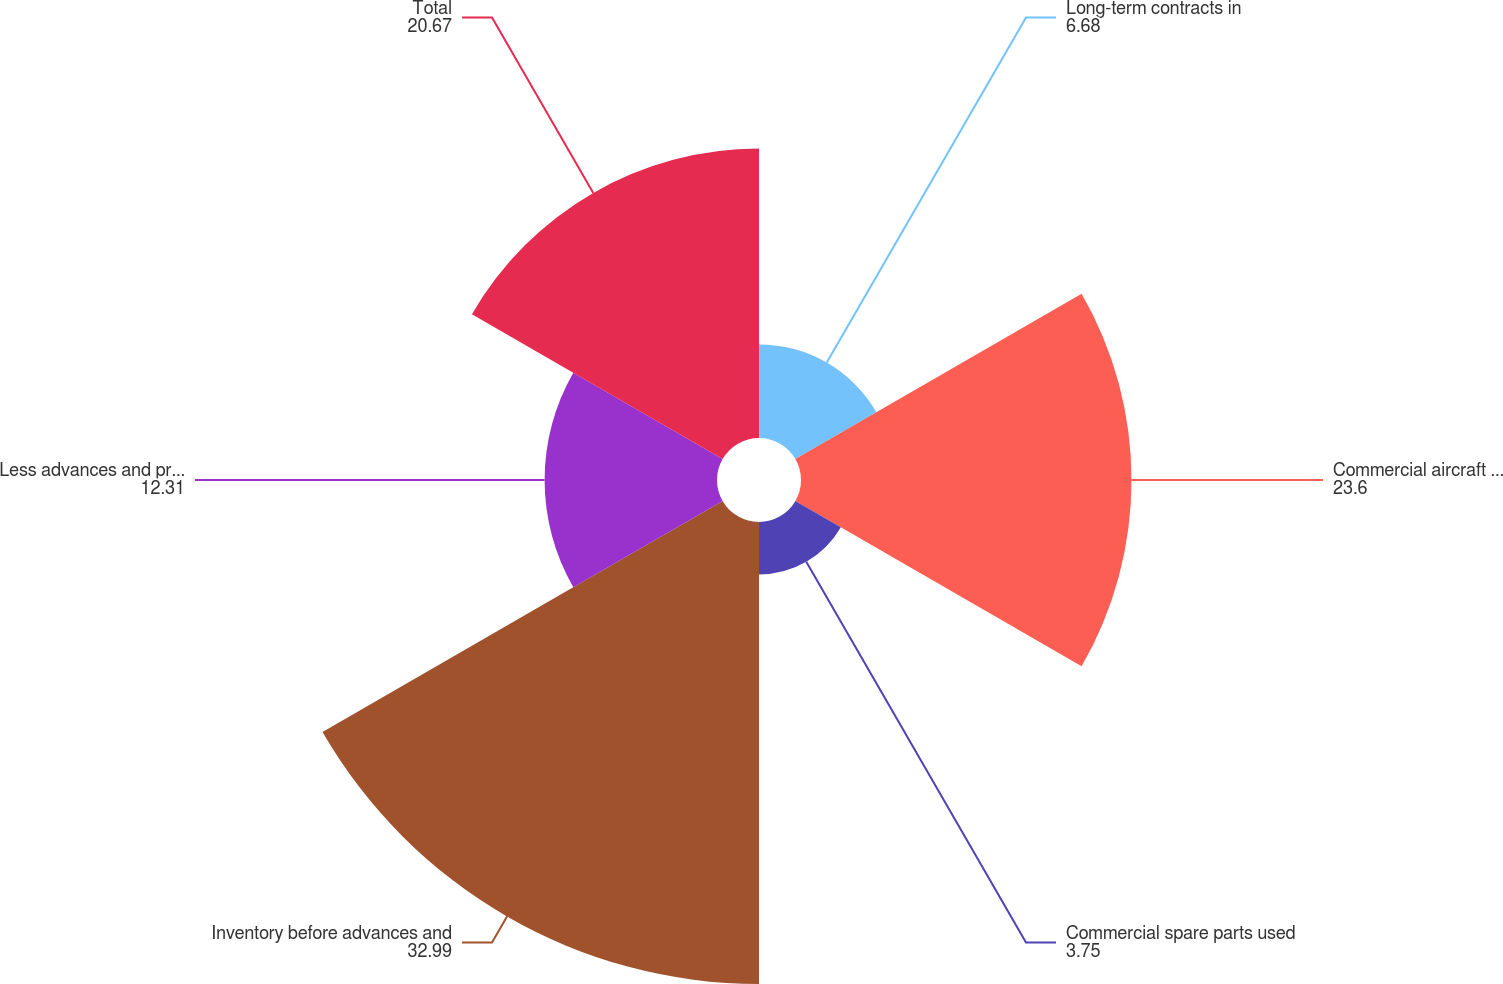Convert chart. <chart><loc_0><loc_0><loc_500><loc_500><pie_chart><fcel>Long-term contracts in<fcel>Commercial aircraft programs<fcel>Commercial spare parts used<fcel>Inventory before advances and<fcel>Less advances and progress<fcel>Total<nl><fcel>6.68%<fcel>23.6%<fcel>3.75%<fcel>32.99%<fcel>12.31%<fcel>20.67%<nl></chart> 